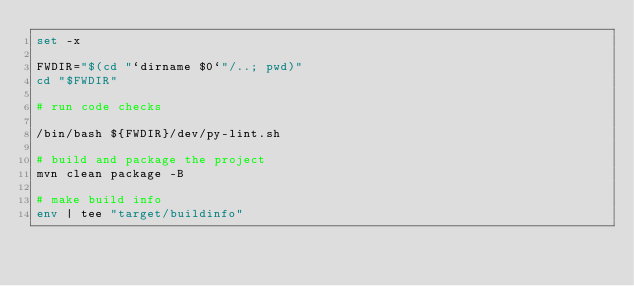<code> <loc_0><loc_0><loc_500><loc_500><_Bash_>set -x

FWDIR="$(cd "`dirname $0`"/..; pwd)"
cd "$FWDIR"

# run code checks

/bin/bash ${FWDIR}/dev/py-lint.sh

# build and package the project
mvn clean package -B

# make build info
env | tee "target/buildinfo" 
</code> 